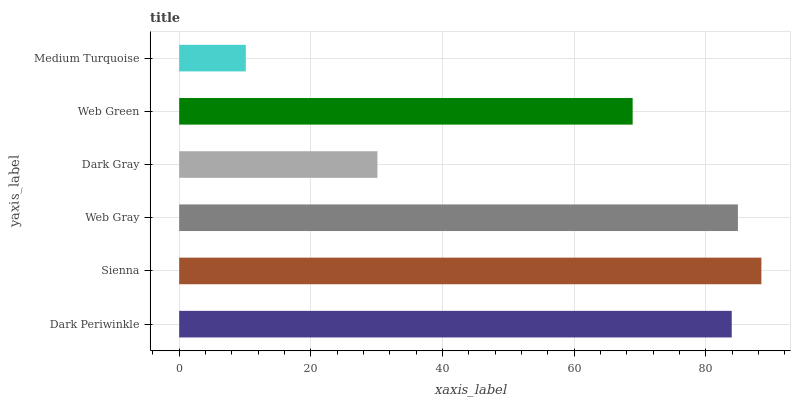Is Medium Turquoise the minimum?
Answer yes or no. Yes. Is Sienna the maximum?
Answer yes or no. Yes. Is Web Gray the minimum?
Answer yes or no. No. Is Web Gray the maximum?
Answer yes or no. No. Is Sienna greater than Web Gray?
Answer yes or no. Yes. Is Web Gray less than Sienna?
Answer yes or no. Yes. Is Web Gray greater than Sienna?
Answer yes or no. No. Is Sienna less than Web Gray?
Answer yes or no. No. Is Dark Periwinkle the high median?
Answer yes or no. Yes. Is Web Green the low median?
Answer yes or no. Yes. Is Web Green the high median?
Answer yes or no. No. Is Dark Periwinkle the low median?
Answer yes or no. No. 